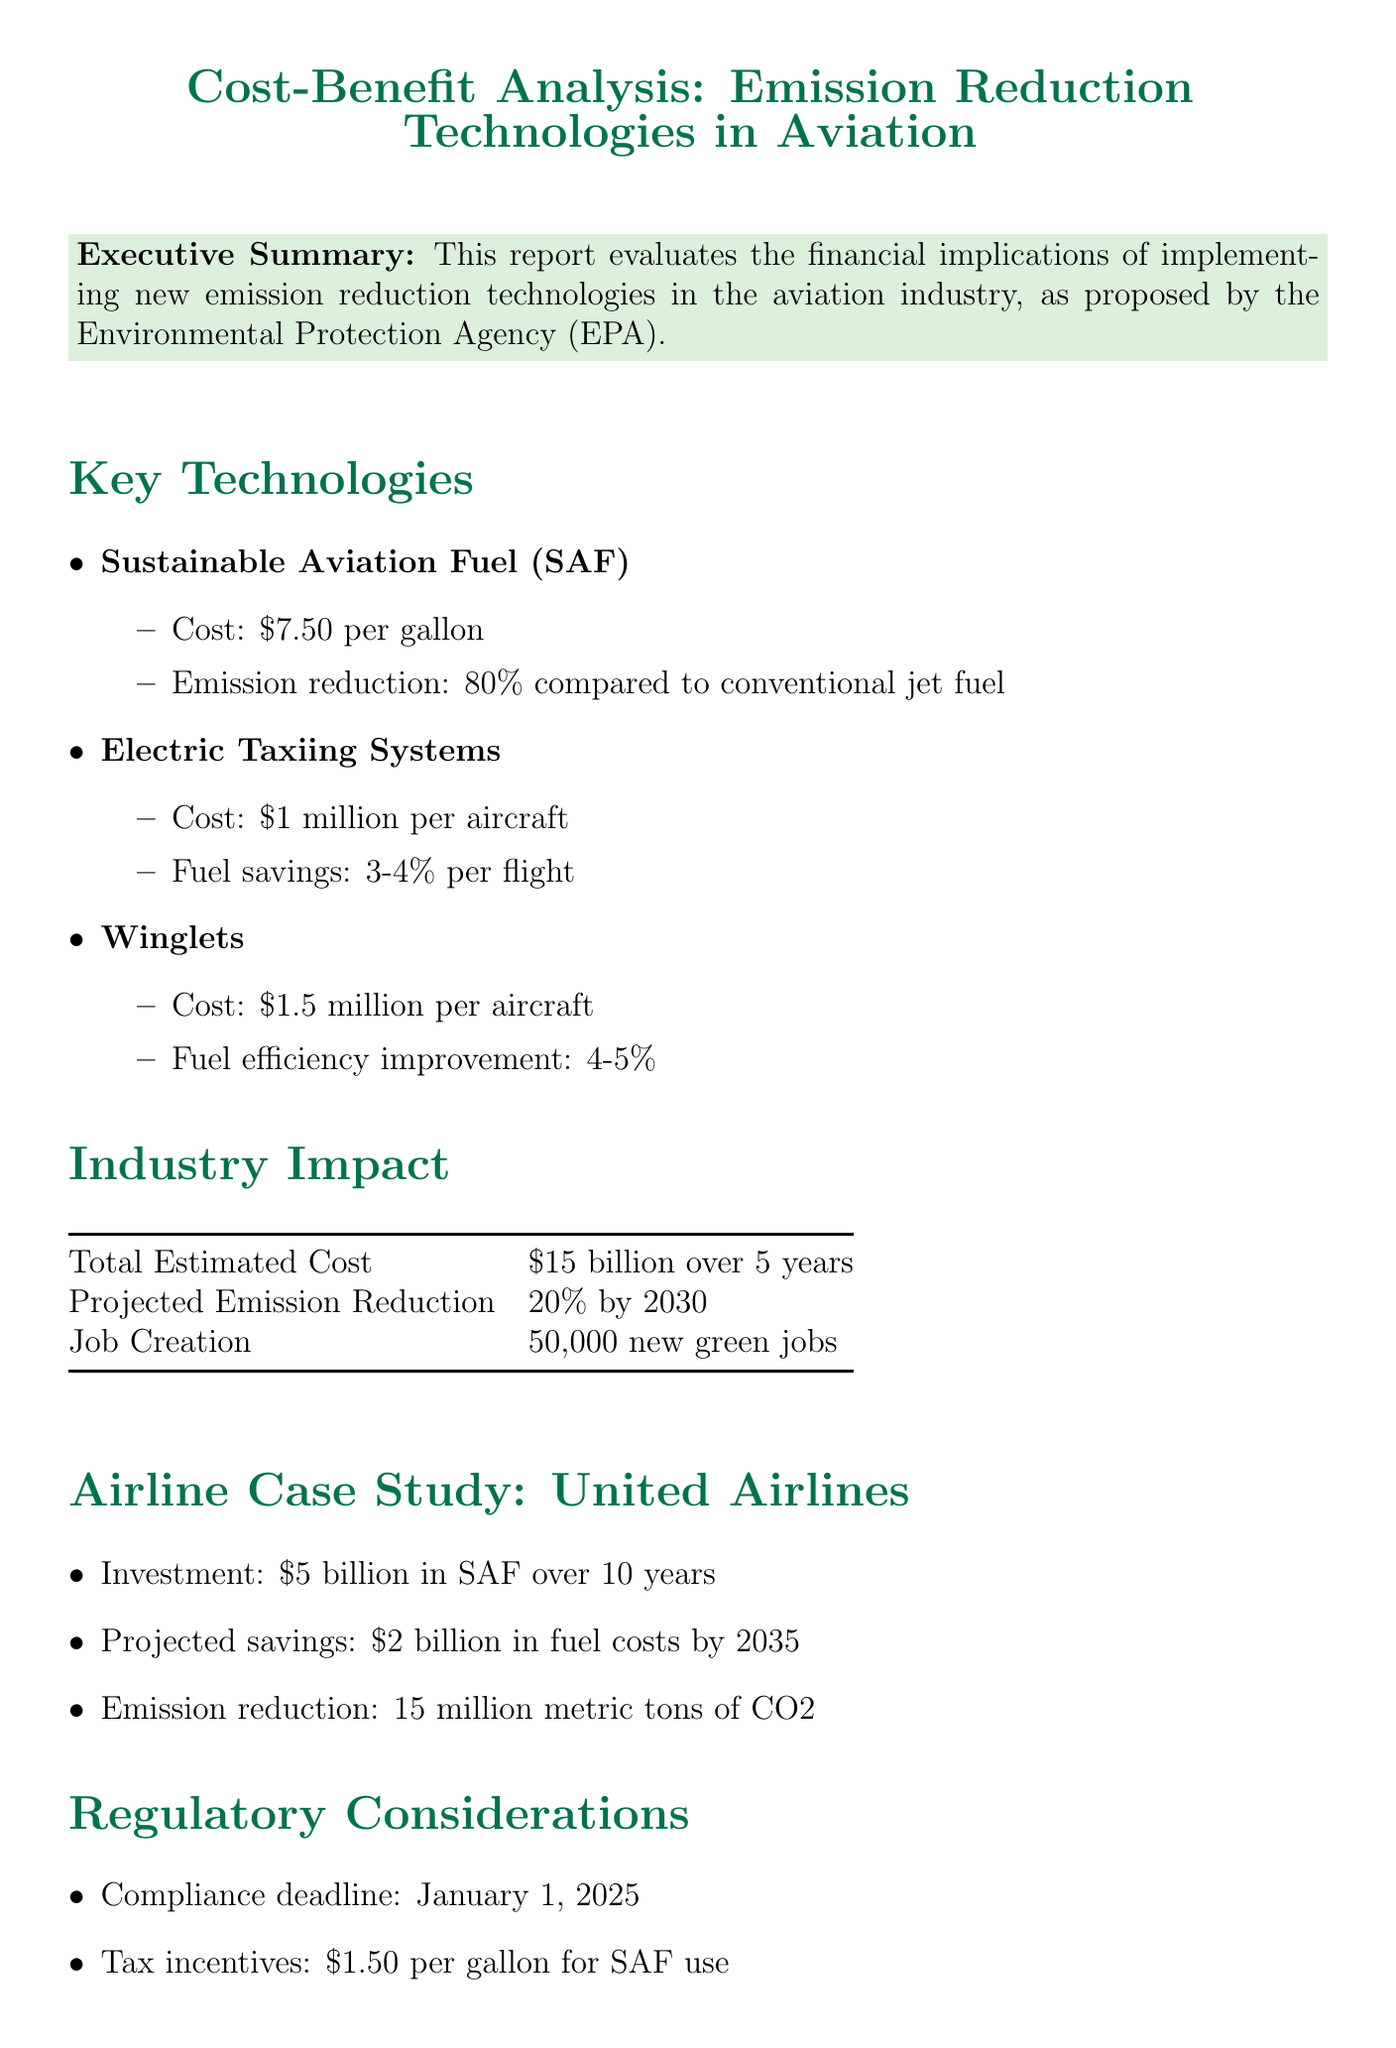What is the total estimated cost of implementing emission reduction technologies? The total estimated cost is presented in the Industry Impact section, which states $15 billion over 5 years.
Answer: $15 billion over 5 years What is the compliance deadline for the new regulations? The compliance deadline is specified in the Regulatory Considerations section as January 1, 2025.
Answer: January 1, 2025 How many new green jobs are projected to be created? The Industry Impact section details the job creation estimate, which is 50,000 new green jobs.
Answer: 50,000 new green jobs What is the cost of Sustainable Aviation Fuel (SAF) per gallon? The Key Technologies section lists the cost of SAF as $7.50 per gallon.
Answer: $7.50 per gallon What percentage of emission reduction is expected from Sustainable Aviation Fuel (SAF)? The emission reduction percentage for SAF is stated as 80% compared to conventional jet fuel in the Key Technologies section.
Answer: 80% How much is United Airlines projected to save in fuel costs by 2035? The projected savings for United Airlines are mentioned in the case study, which states $2 billion in fuel costs by 2035.
Answer: $2 billion What emissions reduction is projected for the aviation industry by 2030? The anticipated emission reduction by 2030 is detailed in the Industry Impact section, indicating a 20% reduction.
Answer: 20% What are the penalties for non-compliance with the regulations? The Regulatory Considerations section specifies the penalties as up to $37,500 per day for non-compliance.
Answer: Up to $37,500 per day 